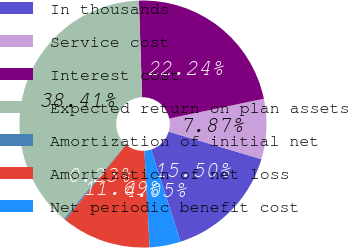Convert chart. <chart><loc_0><loc_0><loc_500><loc_500><pie_chart><fcel>In thousands<fcel>Service cost<fcel>Interest cost<fcel>Expected return on plan assets<fcel>Amortization of initial net<fcel>Amortization of net loss<fcel>Net periodic benefit cost<nl><fcel>15.5%<fcel>7.87%<fcel>22.24%<fcel>38.41%<fcel>0.23%<fcel>11.69%<fcel>4.05%<nl></chart> 